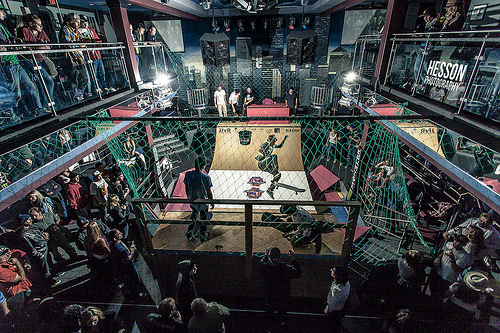<image>
Can you confirm if the skater is on the man? No. The skater is not positioned on the man. They may be near each other, but the skater is not supported by or resting on top of the man. 